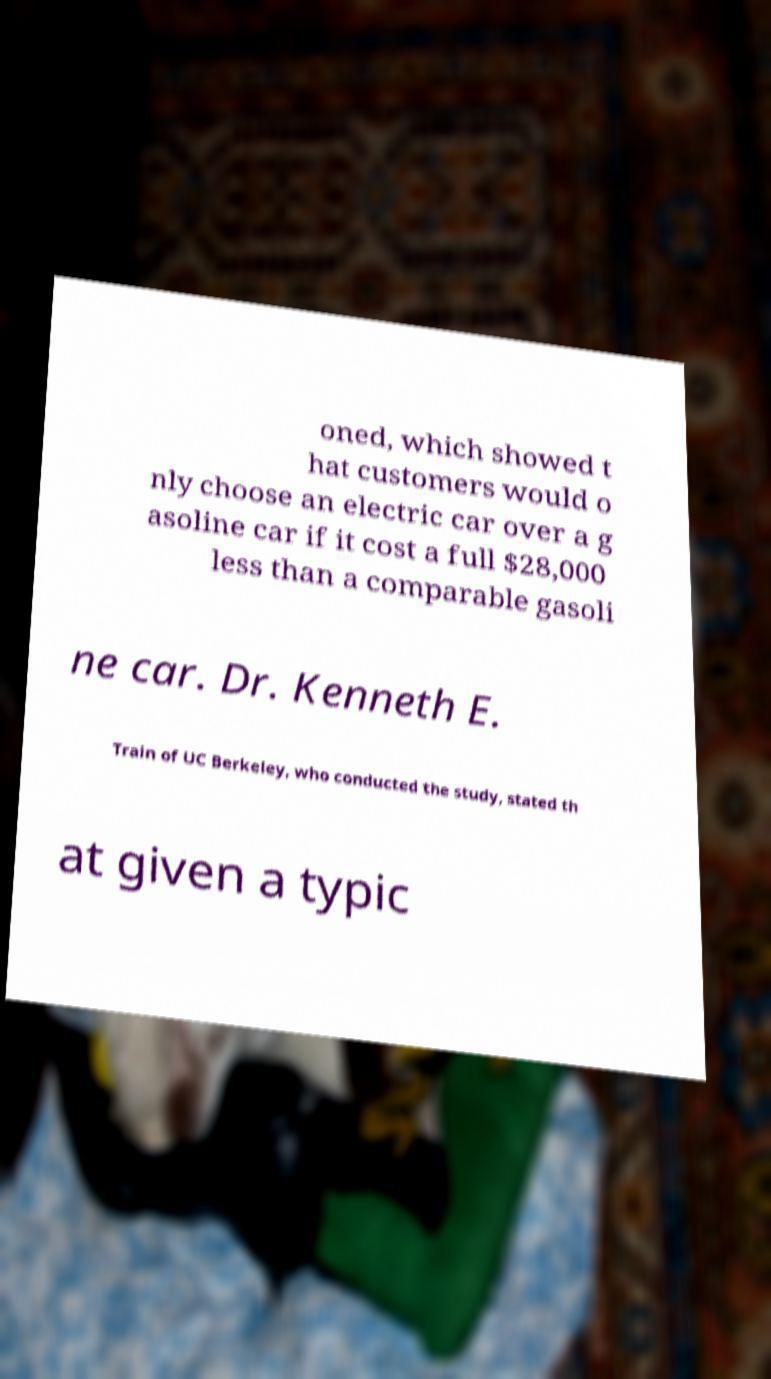Could you assist in decoding the text presented in this image and type it out clearly? oned, which showed t hat customers would o nly choose an electric car over a g asoline car if it cost a full $28,000 less than a comparable gasoli ne car. Dr. Kenneth E. Train of UC Berkeley, who conducted the study, stated th at given a typic 